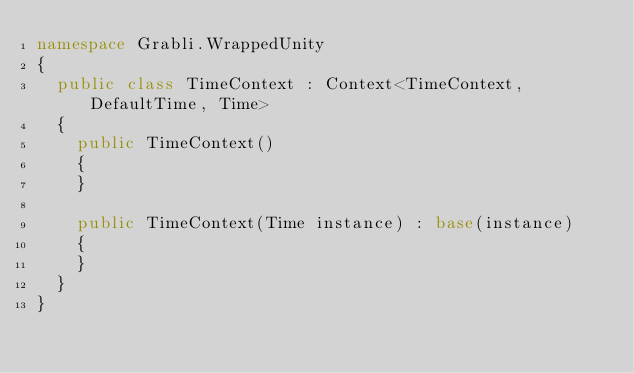Convert code to text. <code><loc_0><loc_0><loc_500><loc_500><_C#_>namespace Grabli.WrappedUnity
{
	public class TimeContext : Context<TimeContext, DefaultTime, Time>
	{
		public TimeContext()
		{
		}

		public TimeContext(Time instance) : base(instance)
		{
		}
	}
}
</code> 